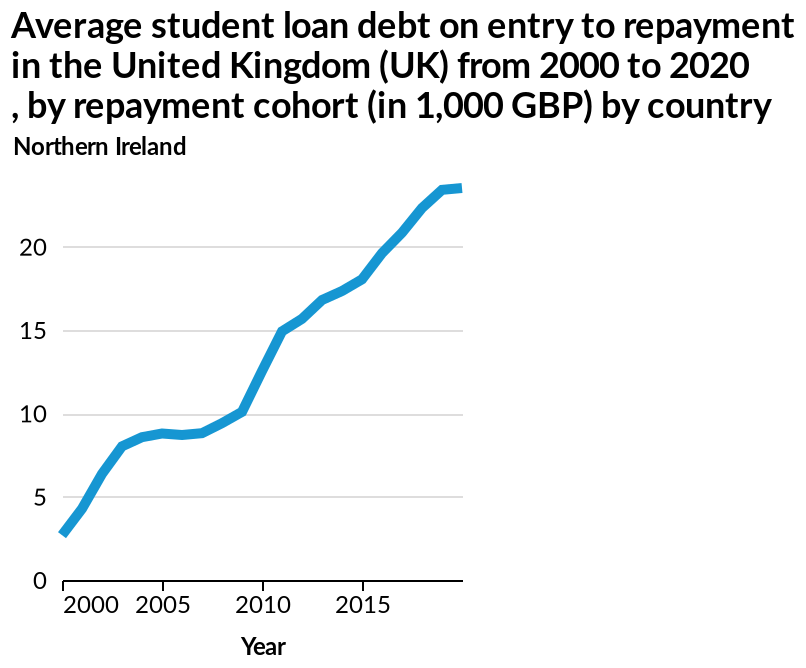<image>
please summary the statistics and relations of the chart The average student debt has risen dramatically since 2000. It stabilised a little in the early 2000's but then rose again massively. What was the average student loan debt on entry to repayment in Northern Ireland in 2000?  The average student loan debt on entry to repayment in Northern Ireland was between £0-£5000 in 2000. How did the average student loan debt change between 2000 and 2004?  The average student loan debt increased sharply between 2000 and 2004. 